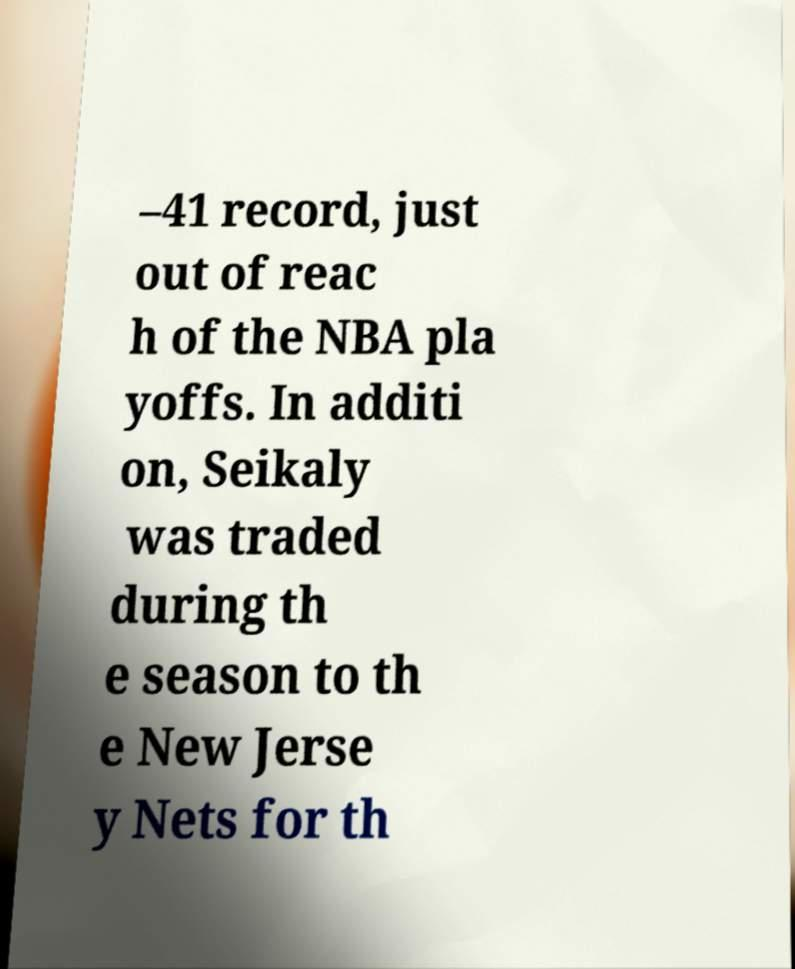Please identify and transcribe the text found in this image. –41 record, just out of reac h of the NBA pla yoffs. In additi on, Seikaly was traded during th e season to th e New Jerse y Nets for th 